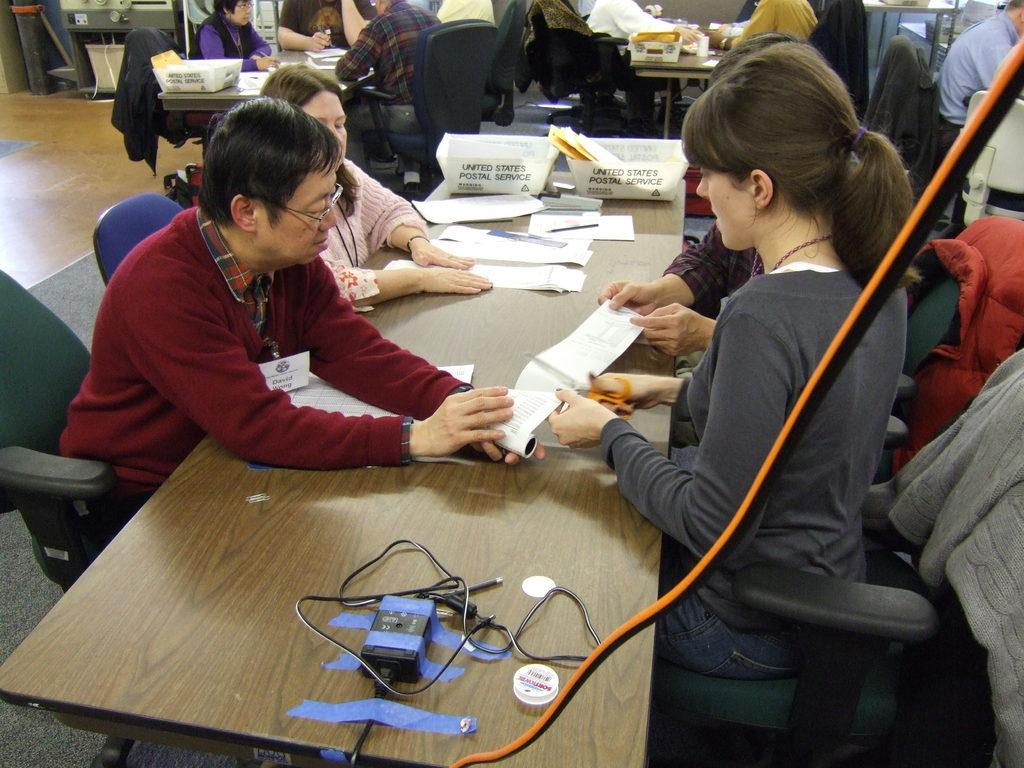What is happening in the image involving a group of people? In the image, there is a group of people sitting on chairs. What are the people doing with their hands? The people have their hands on a table. Are there any other people visible in the image? Yes, there are additional people sitting on chairs in the background. What type of plantation can be seen in the image? There is no plantation present in the image; it features a group of people sitting on chairs with their hands on a table. 